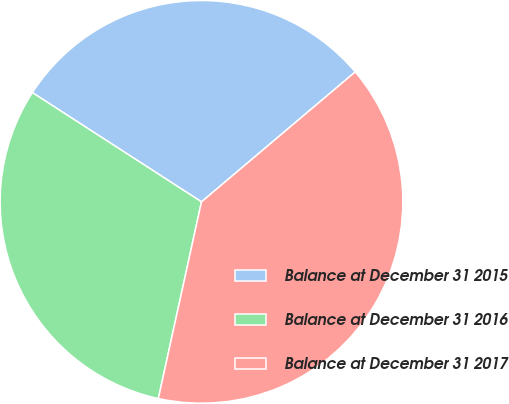Convert chart. <chart><loc_0><loc_0><loc_500><loc_500><pie_chart><fcel>Balance at December 31 2015<fcel>Balance at December 31 2016<fcel>Balance at December 31 2017<nl><fcel>29.7%<fcel>30.69%<fcel>39.6%<nl></chart> 